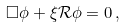<formula> <loc_0><loc_0><loc_500><loc_500>\Box \phi + \xi \mathcal { R } \phi = 0 \, ,</formula> 